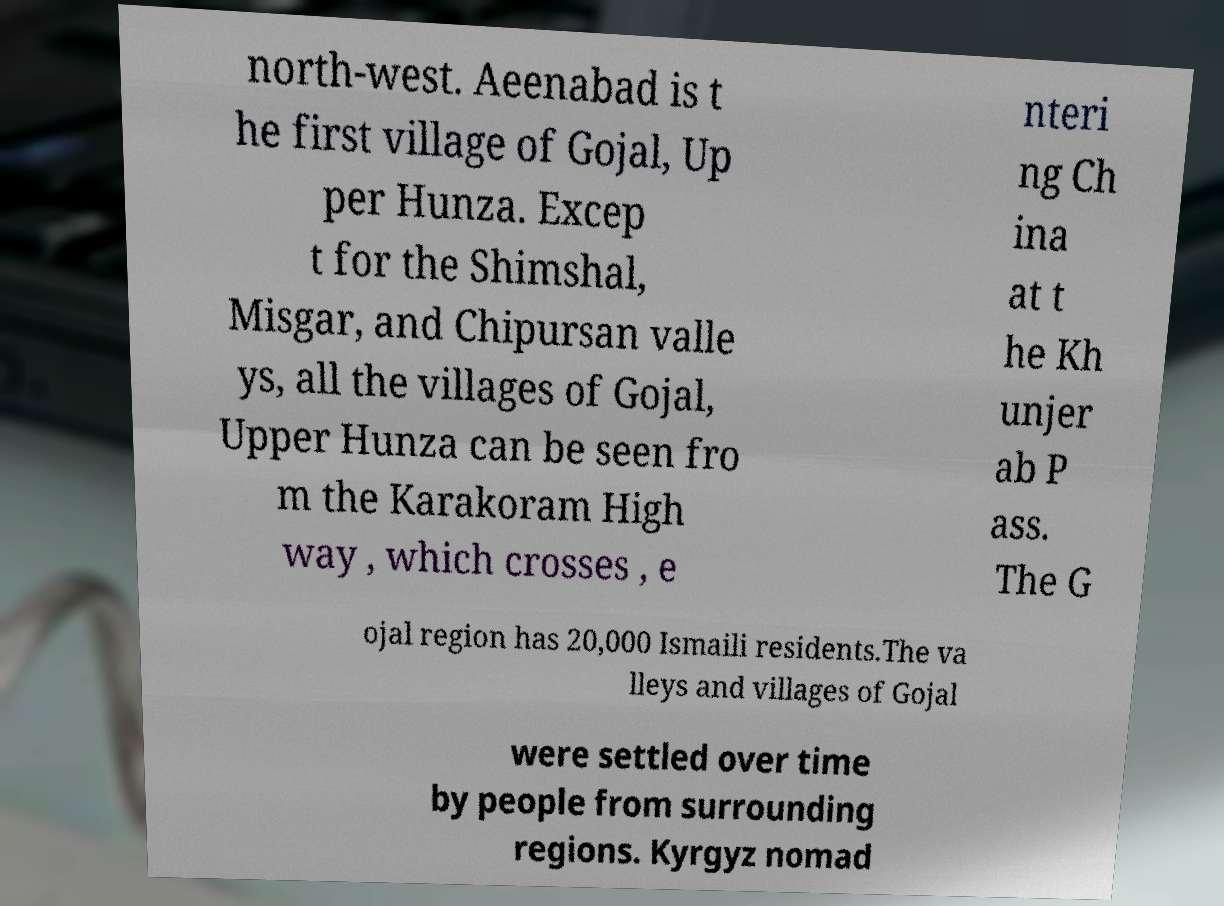What messages or text are displayed in this image? I need them in a readable, typed format. north-west. Aeenabad is t he first village of Gojal, Up per Hunza. Excep t for the Shimshal, Misgar, and Chipursan valle ys, all the villages of Gojal, Upper Hunza can be seen fro m the Karakoram High way , which crosses , e nteri ng Ch ina at t he Kh unjer ab P ass. The G ojal region has 20,000 Ismaili residents.The va lleys and villages of Gojal were settled over time by people from surrounding regions. Kyrgyz nomad 